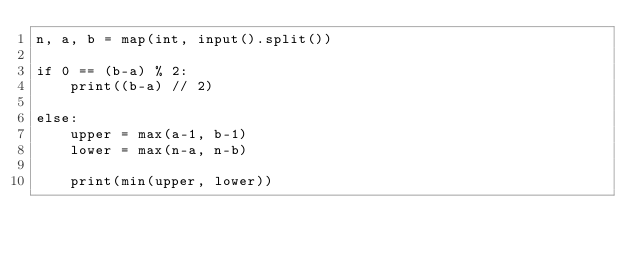Convert code to text. <code><loc_0><loc_0><loc_500><loc_500><_Python_>n, a, b = map(int, input().split())

if 0 == (b-a) % 2:
    print((b-a) // 2)

else:
    upper = max(a-1, b-1)
    lower = max(n-a, n-b)

	print(min(upper, lower))</code> 